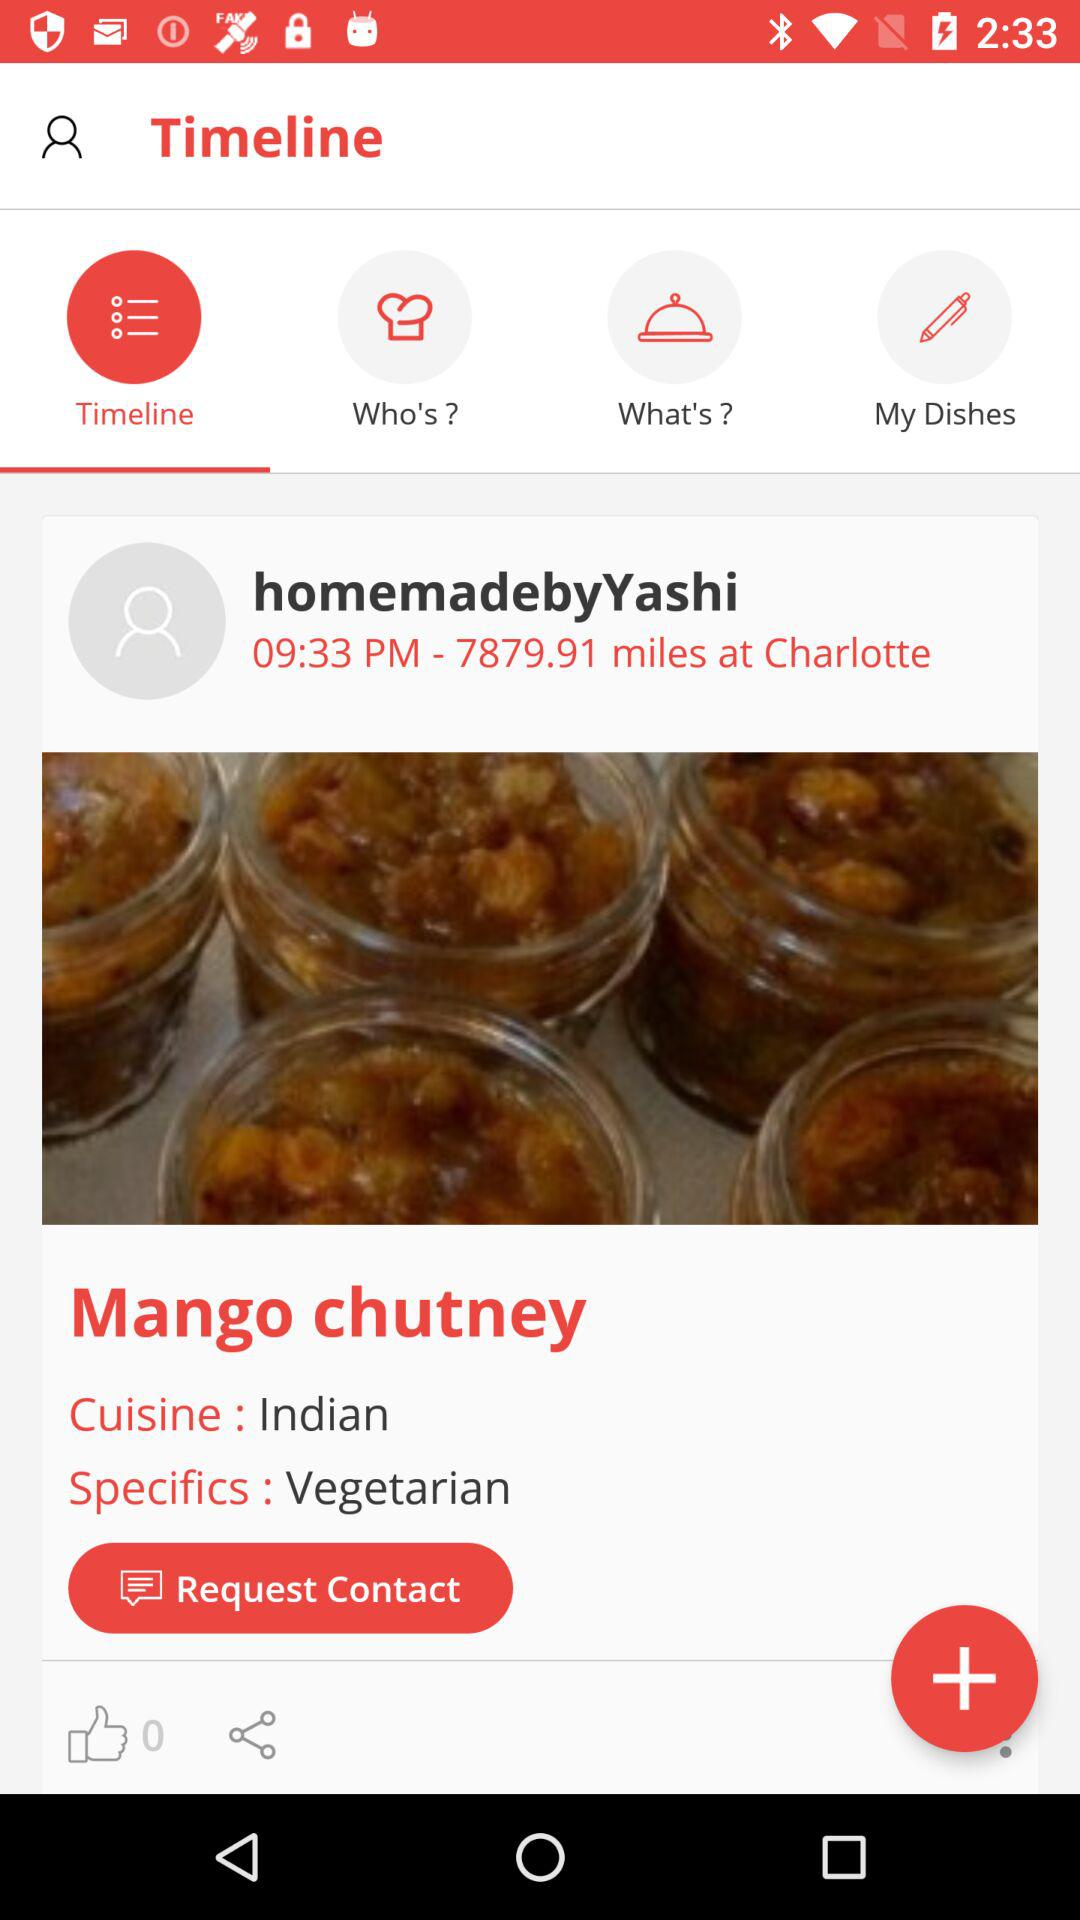What is the time? The time is 9:33 p.m. 